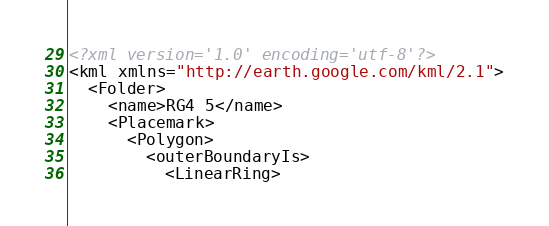<code> <loc_0><loc_0><loc_500><loc_500><_XML_><?xml version='1.0' encoding='utf-8'?>
<kml xmlns="http://earth.google.com/kml/2.1">
  <Folder>
    <name>RG4 5</name>
    <Placemark>
      <Polygon>
        <outerBoundaryIs>
          <LinearRing></code> 